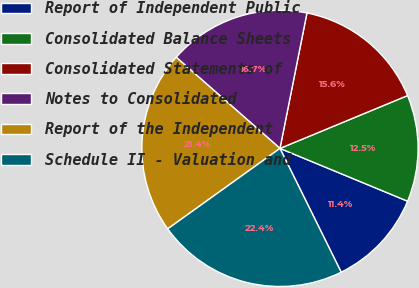Convert chart. <chart><loc_0><loc_0><loc_500><loc_500><pie_chart><fcel>Report of Independent Public<fcel>Consolidated Balance Sheets<fcel>Consolidated Statements of<fcel>Notes to Consolidated<fcel>Report of the Independent<fcel>Schedule II - Valuation and<nl><fcel>11.45%<fcel>12.49%<fcel>15.62%<fcel>16.66%<fcel>21.37%<fcel>22.41%<nl></chart> 